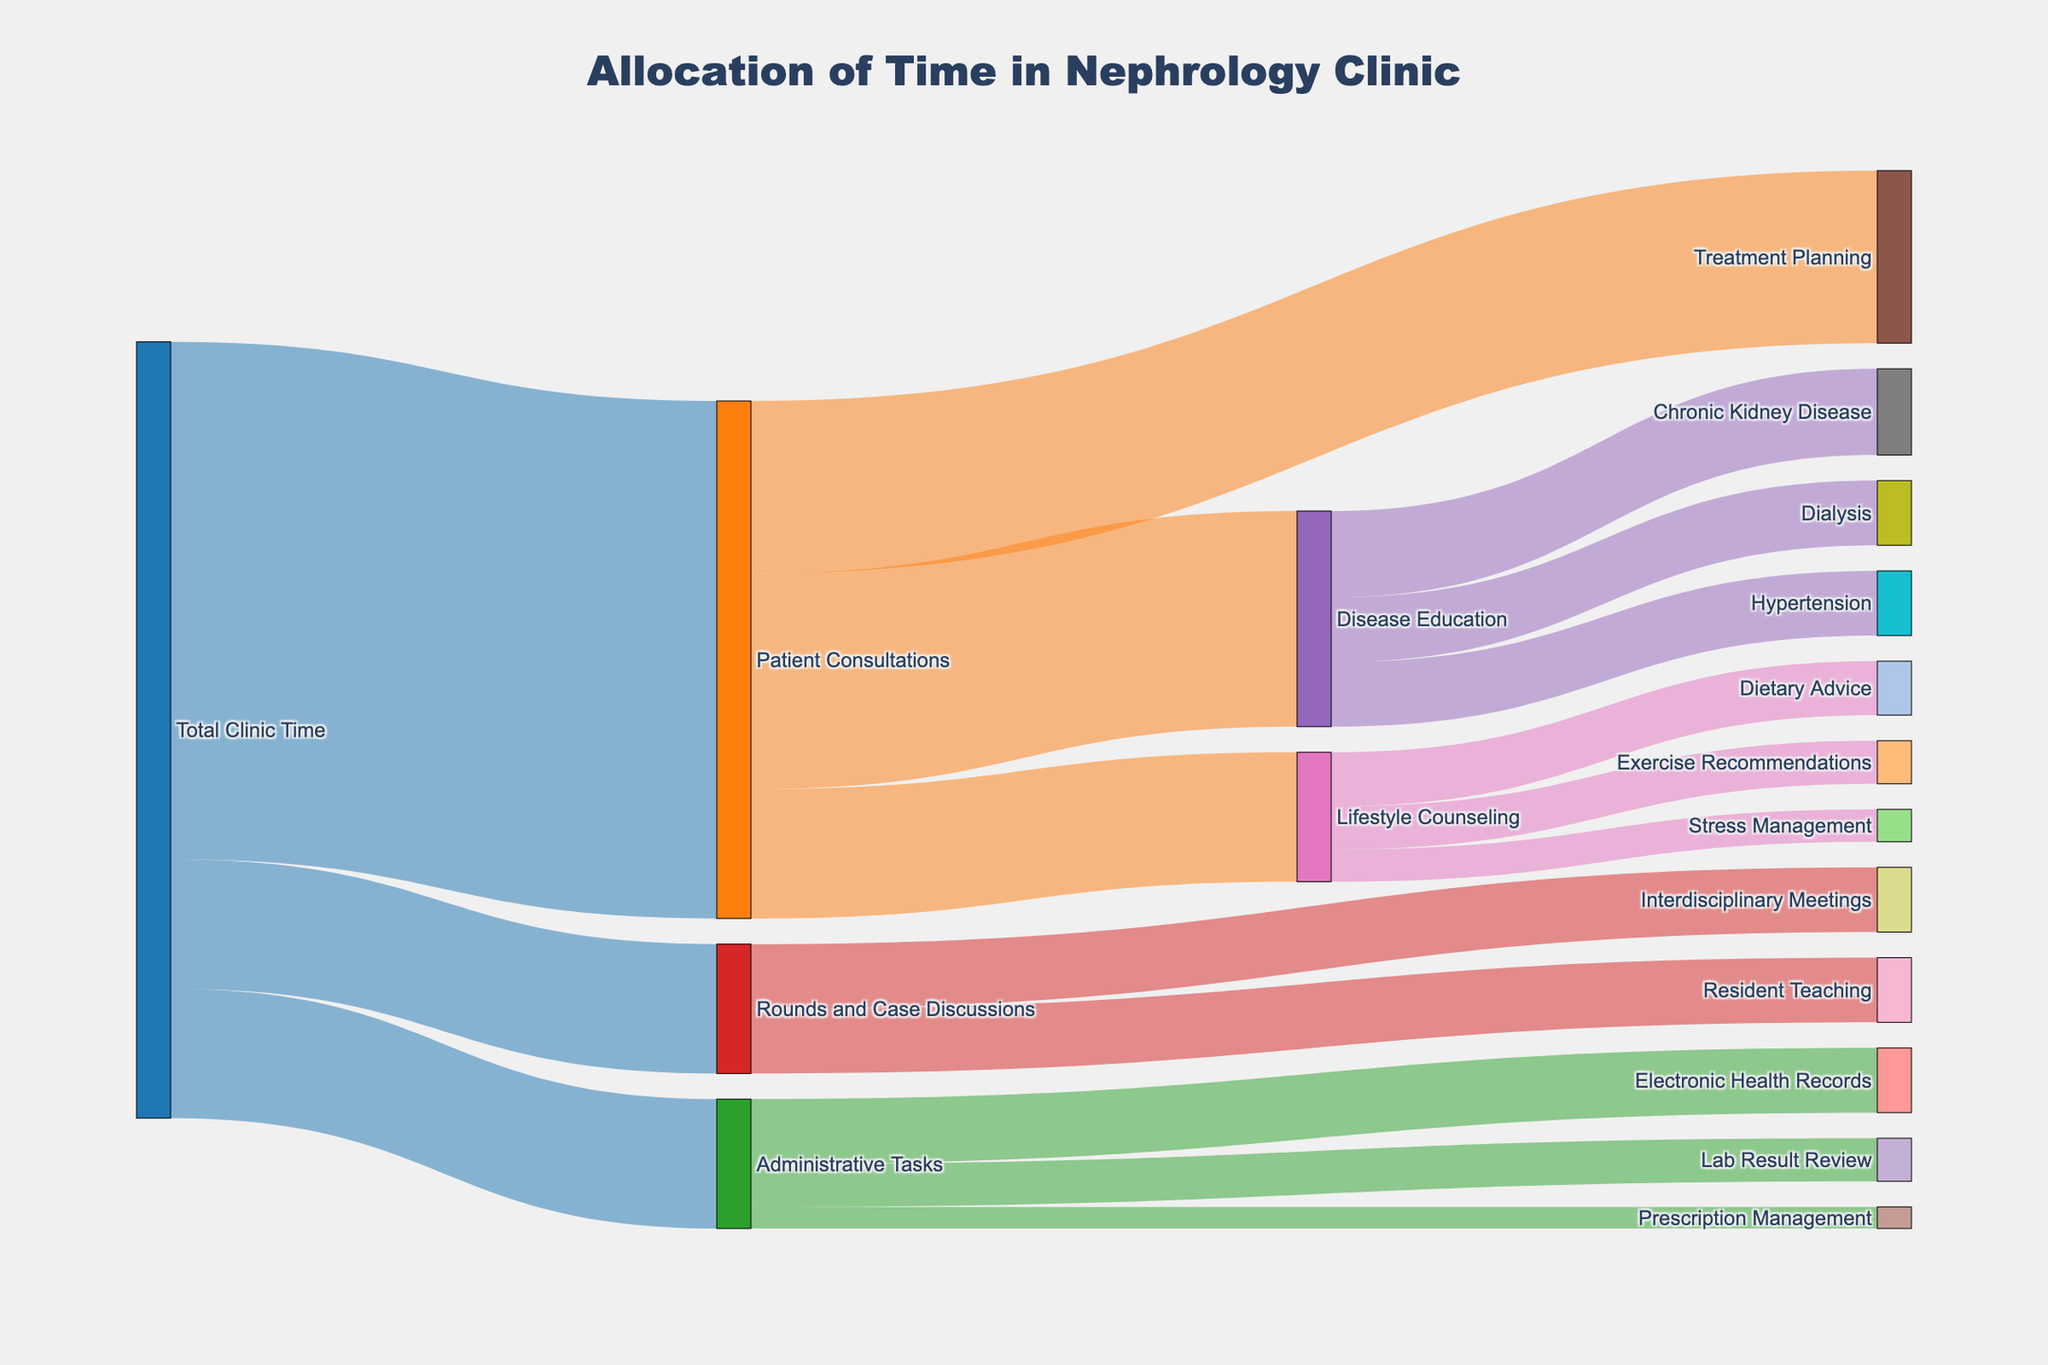What is the title of the plot? The title of the plot is prominently displayed at the top and reads "Allocation of Time in Nephrology Clinic".
Answer: Allocation of Time in Nephrology Clinic How much time is allocated to Patient Consultations? The size of the link from "Total Clinic Time" to "Patient Consultations" is labeled with the value of 240.
Answer: 240 minutes How does the time spent on Administrative Tasks compare to that spent on Disease Education? Administrative Tasks have a link value of 60, while Disease Education receives 100 from Patient Consultations. 100 is greater than 60.
Answer: Disease Education has more time allocated What activities are included under Patient Consultations, and what is their respective time allocation? Under Patient Consultations, the activities are Disease Education (100), Treatment Planning (80), and Lifestyle Counseling (60), adding up to 240. Add the minutes for each of these activities to confirm 100 + 80 + 60 = 240.
Answer: Disease Education (100), Treatment Planning (80), Lifestyle Counseling (60) Which specific topics are covered under Disease Education, and how much time is devoted to each? Chronic Kidney Disease (40), Dialysis (30), and Hypertension (30) are the topics under Disease Education. Check the links from Disease Education to these topics with their values mentioned.
Answer: Chronic Kidney Disease (40), Dialysis (30), Hypertension (30) What are the sub-activities under Lifestyle Counseling, and how much time is allocated to each? Under Lifestyle Counseling, there are Dietary Advice (25), Exercise Recommendations (20), and Stress Management (15). These values can be found where links proceed from Lifestyle Counseling.
Answer: Dietary Advice (25), Exercise Recommendations (20), Stress Management (15) How does the time allocated to Rounds and Case Discussions subdivide? Rounds and Case Discussions splits into Resident Teaching (30) and Interdisciplinary Meetings (30). Since both add up to 60, that splits Rounds and Case Discussions evenly.
Answer: Resident Teaching (30), Interdisciplinary Meetings (30) If you sum the time allocated to different activities under Patient Consultations, does it match the total time devoted to Patient Consultations? The sum of Disease Education (100), Treatment Planning (80), and Lifestyle Counseling (60) equals 240. This matches the total time allocated to Patient Consultations. 100 + 80 + 60 = 240.
Answer: Yes Which activity within Patient Consultations has the least time allocated, and how much is it? Within Patient Consultations, Lifestyle Counseling has the least time allocated with 60 minutes. Compare more granular values to verify.
Answer: Lifestyle Counseling (60) Comparing Electronic Health Records and Resident Teaching, which one has more time allocated? Comparing Electronic Health Records (30) and Resident Teaching (30), they both have equal time allocations. Look at their respective values.
Answer: Both have equal time (30) 